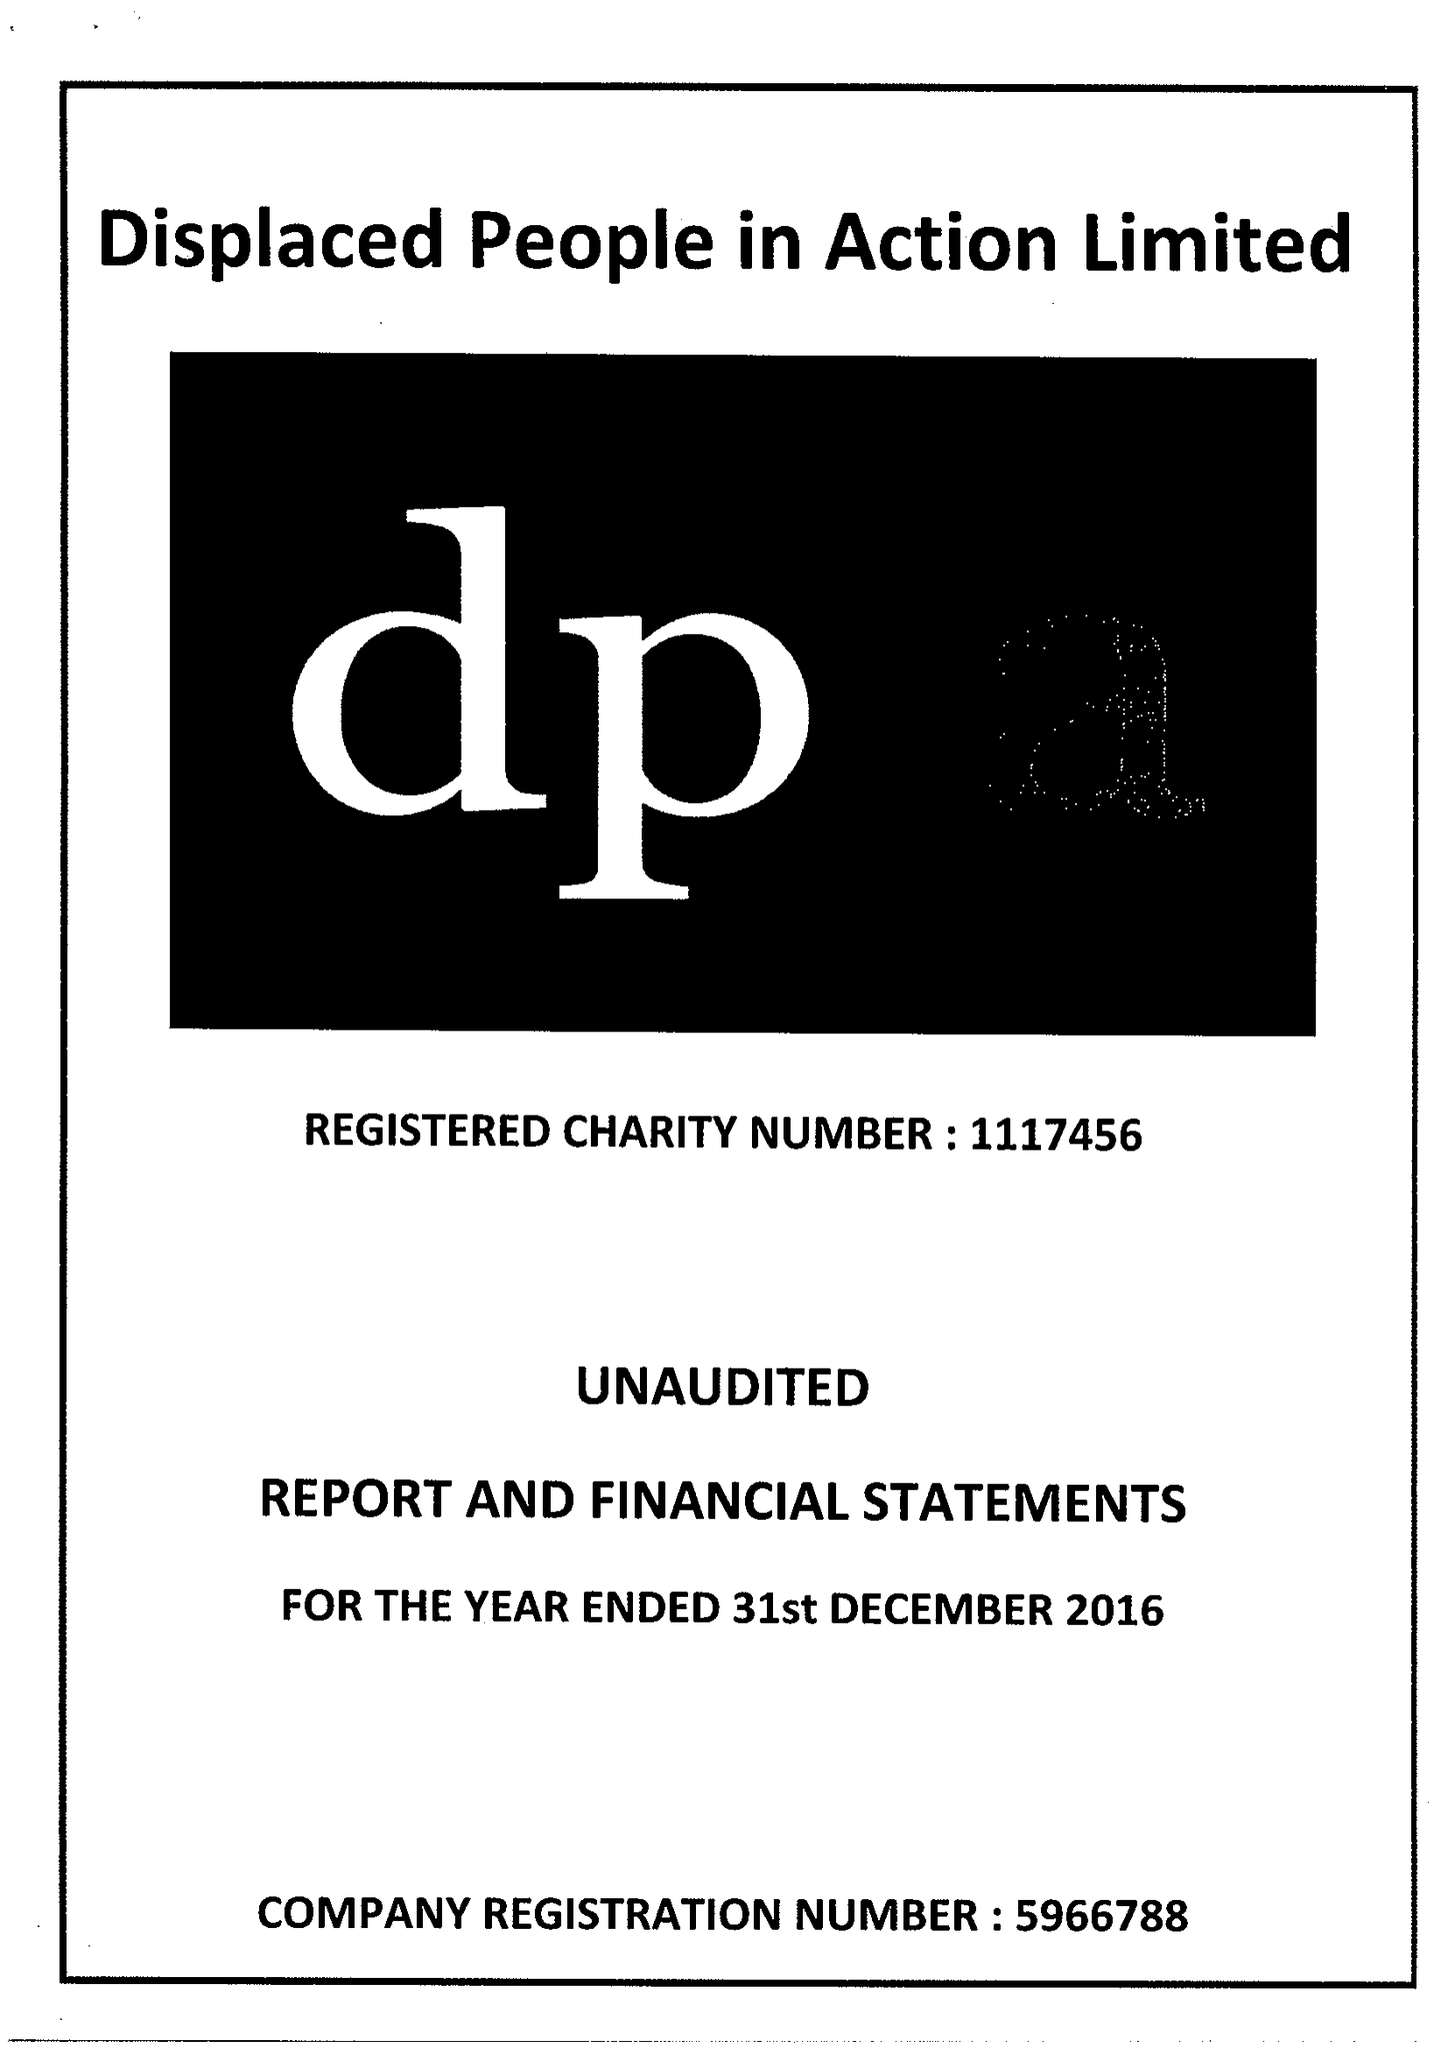What is the value for the address__post_town?
Answer the question using a single word or phrase. CARDIFF 